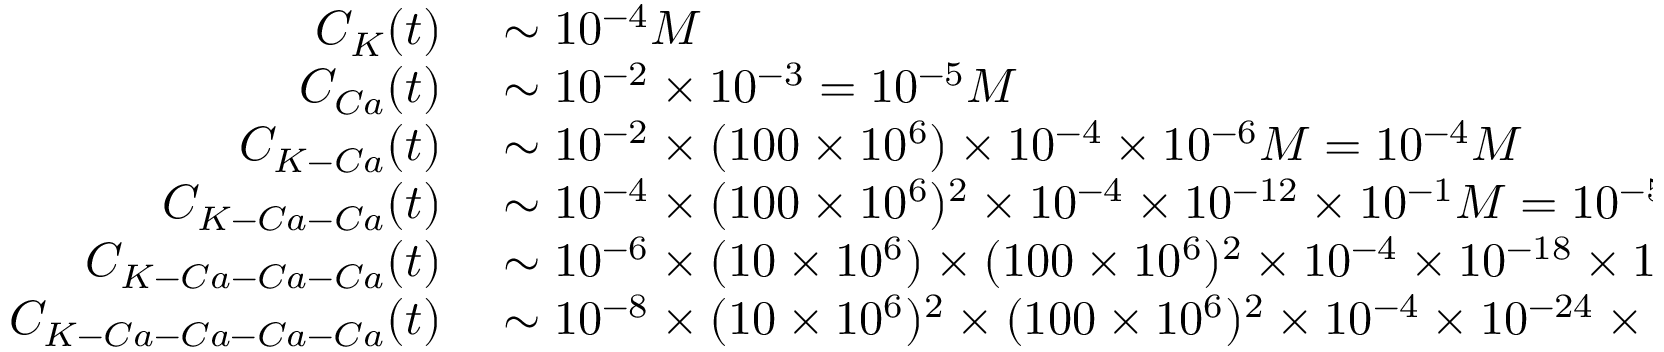Convert formula to latex. <formula><loc_0><loc_0><loc_500><loc_500>\begin{array} { r l } { C _ { K } ( t ) } & \sim 1 0 ^ { - 4 } M } \\ { C _ { C a } ( t ) } & \sim 1 0 ^ { - 2 } \times 1 0 ^ { - 3 } = 1 0 ^ { - 5 } M } \\ { C _ { K - C a } ( t ) } & \sim 1 0 ^ { - 2 } \times ( 1 0 0 \times 1 0 ^ { 6 } ) \times 1 0 ^ { - 4 } \times 1 0 ^ { - 6 } M = 1 0 ^ { - 4 } M } \\ { C _ { K - C a - C a } ( t ) } & \sim 1 0 ^ { - 4 } \times ( 1 0 0 \times 1 0 ^ { 6 } ) ^ { 2 } \times 1 0 ^ { - 4 } \times 1 0 ^ { - 1 2 } \times 1 0 ^ { - 1 } M = 1 0 ^ { - 5 } M } \\ { C _ { K - C a - C a - C a } ( t ) } & \sim 1 0 ^ { - 6 } \times ( 1 0 \times 1 0 ^ { 6 } ) \times ( 1 0 0 \times 1 0 ^ { 6 } ) ^ { 2 } \times 1 0 ^ { - 4 } \times 1 0 ^ { - 1 8 } \times 1 0 ^ { - 1 } M = 1 0 ^ { - 6 } M } \\ { C _ { K - C a - C a - C a - C a } ( t ) } & \sim 1 0 ^ { - 8 } \times ( 1 0 \times 1 0 ^ { 6 } ) ^ { 2 } \times ( 1 0 0 \times 1 0 ^ { 6 } ) ^ { 2 } \times 1 0 ^ { - 4 } \times 1 0 ^ { - 2 4 } \times 1 0 ^ { - 2 } M = 1 0 ^ { - 8 } M } \end{array}</formula> 